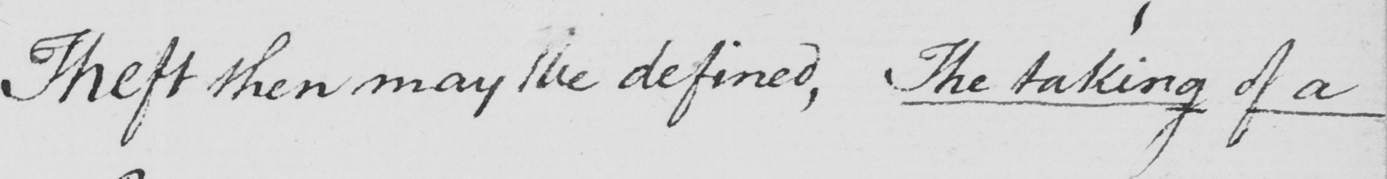Please provide the text content of this handwritten line. Theft then may be defined , The taking of a 